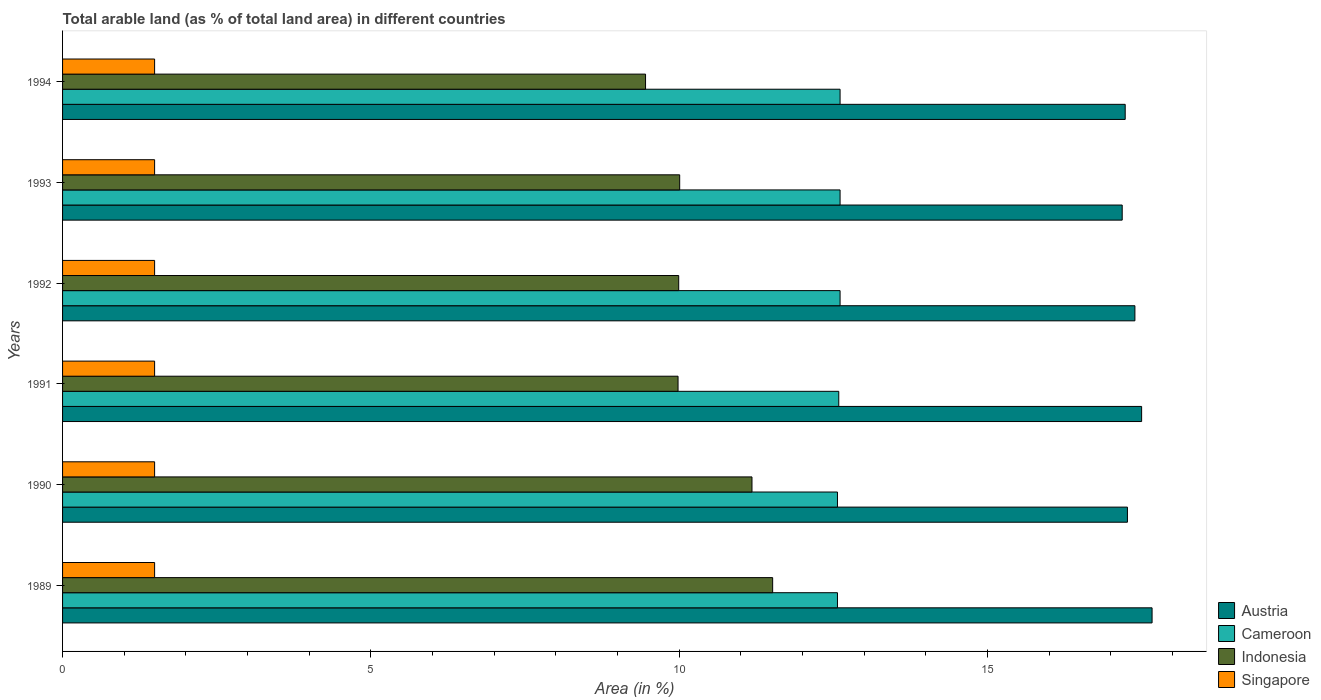How many groups of bars are there?
Provide a succinct answer. 6. Are the number of bars per tick equal to the number of legend labels?
Provide a succinct answer. Yes. Are the number of bars on each tick of the Y-axis equal?
Your answer should be very brief. Yes. How many bars are there on the 5th tick from the top?
Your answer should be compact. 4. How many bars are there on the 3rd tick from the bottom?
Provide a short and direct response. 4. What is the label of the 2nd group of bars from the top?
Give a very brief answer. 1993. What is the percentage of arable land in Austria in 1989?
Give a very brief answer. 17.67. Across all years, what is the maximum percentage of arable land in Singapore?
Offer a very short reply. 1.49. Across all years, what is the minimum percentage of arable land in Singapore?
Provide a short and direct response. 1.49. What is the total percentage of arable land in Austria in the graph?
Your response must be concise. 104.24. What is the difference between the percentage of arable land in Austria in 1992 and that in 1994?
Your response must be concise. 0.16. What is the difference between the percentage of arable land in Austria in 1992 and the percentage of arable land in Indonesia in 1991?
Ensure brevity in your answer.  7.41. What is the average percentage of arable land in Singapore per year?
Provide a short and direct response. 1.49. In the year 1992, what is the difference between the percentage of arable land in Indonesia and percentage of arable land in Cameroon?
Give a very brief answer. -2.62. What is the ratio of the percentage of arable land in Indonesia in 1990 to that in 1992?
Provide a succinct answer. 1.12. Is the difference between the percentage of arable land in Indonesia in 1992 and 1993 greater than the difference between the percentage of arable land in Cameroon in 1992 and 1993?
Provide a succinct answer. No. What is the difference between the highest and the lowest percentage of arable land in Austria?
Provide a succinct answer. 0.48. Is it the case that in every year, the sum of the percentage of arable land in Indonesia and percentage of arable land in Austria is greater than the sum of percentage of arable land in Singapore and percentage of arable land in Cameroon?
Your answer should be very brief. Yes. What does the 1st bar from the top in 1989 represents?
Give a very brief answer. Singapore. What does the 1st bar from the bottom in 1989 represents?
Keep it short and to the point. Austria. Are all the bars in the graph horizontal?
Ensure brevity in your answer.  Yes. What is the difference between two consecutive major ticks on the X-axis?
Keep it short and to the point. 5. Does the graph contain grids?
Your answer should be very brief. No. Where does the legend appear in the graph?
Keep it short and to the point. Bottom right. How many legend labels are there?
Provide a succinct answer. 4. How are the legend labels stacked?
Offer a terse response. Vertical. What is the title of the graph?
Give a very brief answer. Total arable land (as % of total land area) in different countries. Does "Mali" appear as one of the legend labels in the graph?
Provide a short and direct response. No. What is the label or title of the X-axis?
Provide a short and direct response. Area (in %). What is the Area (in %) in Austria in 1989?
Offer a terse response. 17.67. What is the Area (in %) in Cameroon in 1989?
Your answer should be compact. 12.57. What is the Area (in %) in Indonesia in 1989?
Provide a succinct answer. 11.51. What is the Area (in %) in Singapore in 1989?
Offer a very short reply. 1.49. What is the Area (in %) in Austria in 1990?
Provide a short and direct response. 17.27. What is the Area (in %) of Cameroon in 1990?
Offer a terse response. 12.57. What is the Area (in %) of Indonesia in 1990?
Your response must be concise. 11.18. What is the Area (in %) in Singapore in 1990?
Offer a terse response. 1.49. What is the Area (in %) of Austria in 1991?
Offer a very short reply. 17.5. What is the Area (in %) of Cameroon in 1991?
Offer a terse response. 12.59. What is the Area (in %) in Indonesia in 1991?
Provide a succinct answer. 9.98. What is the Area (in %) in Singapore in 1991?
Offer a very short reply. 1.49. What is the Area (in %) of Austria in 1992?
Offer a terse response. 17.39. What is the Area (in %) in Cameroon in 1992?
Ensure brevity in your answer.  12.61. What is the Area (in %) in Indonesia in 1992?
Offer a very short reply. 9.99. What is the Area (in %) of Singapore in 1992?
Provide a succinct answer. 1.49. What is the Area (in %) of Austria in 1993?
Offer a very short reply. 17.18. What is the Area (in %) of Cameroon in 1993?
Provide a succinct answer. 12.61. What is the Area (in %) of Indonesia in 1993?
Your response must be concise. 10.01. What is the Area (in %) in Singapore in 1993?
Give a very brief answer. 1.49. What is the Area (in %) of Austria in 1994?
Offer a very short reply. 17.23. What is the Area (in %) of Cameroon in 1994?
Provide a succinct answer. 12.61. What is the Area (in %) in Indonesia in 1994?
Provide a succinct answer. 9.45. What is the Area (in %) of Singapore in 1994?
Provide a succinct answer. 1.49. Across all years, what is the maximum Area (in %) in Austria?
Ensure brevity in your answer.  17.67. Across all years, what is the maximum Area (in %) in Cameroon?
Your answer should be very brief. 12.61. Across all years, what is the maximum Area (in %) of Indonesia?
Keep it short and to the point. 11.51. Across all years, what is the maximum Area (in %) of Singapore?
Ensure brevity in your answer.  1.49. Across all years, what is the minimum Area (in %) of Austria?
Provide a succinct answer. 17.18. Across all years, what is the minimum Area (in %) in Cameroon?
Offer a very short reply. 12.57. Across all years, what is the minimum Area (in %) in Indonesia?
Your answer should be compact. 9.45. Across all years, what is the minimum Area (in %) of Singapore?
Ensure brevity in your answer.  1.49. What is the total Area (in %) in Austria in the graph?
Your response must be concise. 104.24. What is the total Area (in %) of Cameroon in the graph?
Offer a terse response. 75.54. What is the total Area (in %) of Indonesia in the graph?
Offer a very short reply. 62.13. What is the total Area (in %) in Singapore in the graph?
Keep it short and to the point. 8.96. What is the difference between the Area (in %) in Austria in 1989 and that in 1990?
Provide a short and direct response. 0.4. What is the difference between the Area (in %) of Indonesia in 1989 and that in 1990?
Offer a terse response. 0.34. What is the difference between the Area (in %) of Singapore in 1989 and that in 1990?
Ensure brevity in your answer.  0. What is the difference between the Area (in %) of Austria in 1989 and that in 1991?
Keep it short and to the point. 0.17. What is the difference between the Area (in %) of Cameroon in 1989 and that in 1991?
Your response must be concise. -0.02. What is the difference between the Area (in %) in Indonesia in 1989 and that in 1991?
Your response must be concise. 1.53. What is the difference between the Area (in %) of Singapore in 1989 and that in 1991?
Provide a succinct answer. 0. What is the difference between the Area (in %) of Austria in 1989 and that in 1992?
Your answer should be very brief. 0.28. What is the difference between the Area (in %) in Cameroon in 1989 and that in 1992?
Offer a very short reply. -0.04. What is the difference between the Area (in %) in Indonesia in 1989 and that in 1992?
Provide a short and direct response. 1.52. What is the difference between the Area (in %) of Austria in 1989 and that in 1993?
Provide a succinct answer. 0.48. What is the difference between the Area (in %) in Cameroon in 1989 and that in 1993?
Provide a succinct answer. -0.04. What is the difference between the Area (in %) of Indonesia in 1989 and that in 1993?
Offer a terse response. 1.51. What is the difference between the Area (in %) in Austria in 1989 and that in 1994?
Offer a very short reply. 0.44. What is the difference between the Area (in %) of Cameroon in 1989 and that in 1994?
Your response must be concise. -0.04. What is the difference between the Area (in %) in Indonesia in 1989 and that in 1994?
Ensure brevity in your answer.  2.06. What is the difference between the Area (in %) in Austria in 1990 and that in 1991?
Your answer should be compact. -0.23. What is the difference between the Area (in %) of Cameroon in 1990 and that in 1991?
Offer a terse response. -0.02. What is the difference between the Area (in %) in Indonesia in 1990 and that in 1991?
Your answer should be very brief. 1.2. What is the difference between the Area (in %) of Austria in 1990 and that in 1992?
Make the answer very short. -0.12. What is the difference between the Area (in %) in Cameroon in 1990 and that in 1992?
Make the answer very short. -0.04. What is the difference between the Area (in %) of Indonesia in 1990 and that in 1992?
Your answer should be compact. 1.19. What is the difference between the Area (in %) in Austria in 1990 and that in 1993?
Your response must be concise. 0.08. What is the difference between the Area (in %) of Cameroon in 1990 and that in 1993?
Provide a succinct answer. -0.04. What is the difference between the Area (in %) of Indonesia in 1990 and that in 1993?
Your answer should be compact. 1.17. What is the difference between the Area (in %) in Singapore in 1990 and that in 1993?
Your answer should be compact. 0. What is the difference between the Area (in %) in Austria in 1990 and that in 1994?
Your answer should be compact. 0.04. What is the difference between the Area (in %) of Cameroon in 1990 and that in 1994?
Offer a very short reply. -0.04. What is the difference between the Area (in %) of Indonesia in 1990 and that in 1994?
Your response must be concise. 1.73. What is the difference between the Area (in %) of Austria in 1991 and that in 1992?
Ensure brevity in your answer.  0.11. What is the difference between the Area (in %) of Cameroon in 1991 and that in 1992?
Offer a very short reply. -0.02. What is the difference between the Area (in %) of Indonesia in 1991 and that in 1992?
Give a very brief answer. -0.01. What is the difference between the Area (in %) of Austria in 1991 and that in 1993?
Keep it short and to the point. 0.31. What is the difference between the Area (in %) of Cameroon in 1991 and that in 1993?
Provide a succinct answer. -0.02. What is the difference between the Area (in %) of Indonesia in 1991 and that in 1993?
Offer a very short reply. -0.03. What is the difference between the Area (in %) of Austria in 1991 and that in 1994?
Ensure brevity in your answer.  0.27. What is the difference between the Area (in %) of Cameroon in 1991 and that in 1994?
Your response must be concise. -0.02. What is the difference between the Area (in %) of Indonesia in 1991 and that in 1994?
Make the answer very short. 0.53. What is the difference between the Area (in %) in Austria in 1992 and that in 1993?
Ensure brevity in your answer.  0.21. What is the difference between the Area (in %) of Cameroon in 1992 and that in 1993?
Give a very brief answer. 0. What is the difference between the Area (in %) of Indonesia in 1992 and that in 1993?
Provide a short and direct response. -0.02. What is the difference between the Area (in %) of Austria in 1992 and that in 1994?
Provide a succinct answer. 0.16. What is the difference between the Area (in %) in Indonesia in 1992 and that in 1994?
Give a very brief answer. 0.54. What is the difference between the Area (in %) of Austria in 1993 and that in 1994?
Your response must be concise. -0.05. What is the difference between the Area (in %) in Cameroon in 1993 and that in 1994?
Offer a terse response. 0. What is the difference between the Area (in %) in Indonesia in 1993 and that in 1994?
Give a very brief answer. 0.55. What is the difference between the Area (in %) of Austria in 1989 and the Area (in %) of Cameroon in 1990?
Offer a very short reply. 5.1. What is the difference between the Area (in %) in Austria in 1989 and the Area (in %) in Indonesia in 1990?
Ensure brevity in your answer.  6.49. What is the difference between the Area (in %) of Austria in 1989 and the Area (in %) of Singapore in 1990?
Your answer should be compact. 16.18. What is the difference between the Area (in %) of Cameroon in 1989 and the Area (in %) of Indonesia in 1990?
Make the answer very short. 1.39. What is the difference between the Area (in %) in Cameroon in 1989 and the Area (in %) in Singapore in 1990?
Your response must be concise. 11.07. What is the difference between the Area (in %) of Indonesia in 1989 and the Area (in %) of Singapore in 1990?
Offer a very short reply. 10.02. What is the difference between the Area (in %) in Austria in 1989 and the Area (in %) in Cameroon in 1991?
Offer a terse response. 5.08. What is the difference between the Area (in %) in Austria in 1989 and the Area (in %) in Indonesia in 1991?
Your response must be concise. 7.69. What is the difference between the Area (in %) in Austria in 1989 and the Area (in %) in Singapore in 1991?
Provide a succinct answer. 16.18. What is the difference between the Area (in %) of Cameroon in 1989 and the Area (in %) of Indonesia in 1991?
Give a very brief answer. 2.58. What is the difference between the Area (in %) in Cameroon in 1989 and the Area (in %) in Singapore in 1991?
Provide a short and direct response. 11.07. What is the difference between the Area (in %) in Indonesia in 1989 and the Area (in %) in Singapore in 1991?
Offer a very short reply. 10.02. What is the difference between the Area (in %) in Austria in 1989 and the Area (in %) in Cameroon in 1992?
Ensure brevity in your answer.  5.06. What is the difference between the Area (in %) in Austria in 1989 and the Area (in %) in Indonesia in 1992?
Your answer should be very brief. 7.68. What is the difference between the Area (in %) of Austria in 1989 and the Area (in %) of Singapore in 1992?
Give a very brief answer. 16.18. What is the difference between the Area (in %) in Cameroon in 1989 and the Area (in %) in Indonesia in 1992?
Provide a succinct answer. 2.57. What is the difference between the Area (in %) in Cameroon in 1989 and the Area (in %) in Singapore in 1992?
Your answer should be compact. 11.07. What is the difference between the Area (in %) in Indonesia in 1989 and the Area (in %) in Singapore in 1992?
Give a very brief answer. 10.02. What is the difference between the Area (in %) in Austria in 1989 and the Area (in %) in Cameroon in 1993?
Offer a very short reply. 5.06. What is the difference between the Area (in %) of Austria in 1989 and the Area (in %) of Indonesia in 1993?
Offer a terse response. 7.66. What is the difference between the Area (in %) in Austria in 1989 and the Area (in %) in Singapore in 1993?
Offer a very short reply. 16.18. What is the difference between the Area (in %) in Cameroon in 1989 and the Area (in %) in Indonesia in 1993?
Give a very brief answer. 2.56. What is the difference between the Area (in %) of Cameroon in 1989 and the Area (in %) of Singapore in 1993?
Offer a terse response. 11.07. What is the difference between the Area (in %) of Indonesia in 1989 and the Area (in %) of Singapore in 1993?
Ensure brevity in your answer.  10.02. What is the difference between the Area (in %) of Austria in 1989 and the Area (in %) of Cameroon in 1994?
Your answer should be compact. 5.06. What is the difference between the Area (in %) of Austria in 1989 and the Area (in %) of Indonesia in 1994?
Your answer should be compact. 8.21. What is the difference between the Area (in %) of Austria in 1989 and the Area (in %) of Singapore in 1994?
Offer a terse response. 16.18. What is the difference between the Area (in %) of Cameroon in 1989 and the Area (in %) of Indonesia in 1994?
Offer a terse response. 3.11. What is the difference between the Area (in %) of Cameroon in 1989 and the Area (in %) of Singapore in 1994?
Offer a very short reply. 11.07. What is the difference between the Area (in %) of Indonesia in 1989 and the Area (in %) of Singapore in 1994?
Your answer should be very brief. 10.02. What is the difference between the Area (in %) of Austria in 1990 and the Area (in %) of Cameroon in 1991?
Give a very brief answer. 4.68. What is the difference between the Area (in %) in Austria in 1990 and the Area (in %) in Indonesia in 1991?
Make the answer very short. 7.29. What is the difference between the Area (in %) in Austria in 1990 and the Area (in %) in Singapore in 1991?
Give a very brief answer. 15.78. What is the difference between the Area (in %) of Cameroon in 1990 and the Area (in %) of Indonesia in 1991?
Your answer should be compact. 2.58. What is the difference between the Area (in %) of Cameroon in 1990 and the Area (in %) of Singapore in 1991?
Offer a terse response. 11.07. What is the difference between the Area (in %) in Indonesia in 1990 and the Area (in %) in Singapore in 1991?
Make the answer very short. 9.69. What is the difference between the Area (in %) in Austria in 1990 and the Area (in %) in Cameroon in 1992?
Your response must be concise. 4.66. What is the difference between the Area (in %) of Austria in 1990 and the Area (in %) of Indonesia in 1992?
Your answer should be compact. 7.28. What is the difference between the Area (in %) in Austria in 1990 and the Area (in %) in Singapore in 1992?
Offer a terse response. 15.78. What is the difference between the Area (in %) of Cameroon in 1990 and the Area (in %) of Indonesia in 1992?
Your answer should be compact. 2.57. What is the difference between the Area (in %) in Cameroon in 1990 and the Area (in %) in Singapore in 1992?
Offer a very short reply. 11.07. What is the difference between the Area (in %) of Indonesia in 1990 and the Area (in %) of Singapore in 1992?
Your answer should be compact. 9.69. What is the difference between the Area (in %) of Austria in 1990 and the Area (in %) of Cameroon in 1993?
Keep it short and to the point. 4.66. What is the difference between the Area (in %) in Austria in 1990 and the Area (in %) in Indonesia in 1993?
Ensure brevity in your answer.  7.26. What is the difference between the Area (in %) in Austria in 1990 and the Area (in %) in Singapore in 1993?
Offer a very short reply. 15.78. What is the difference between the Area (in %) in Cameroon in 1990 and the Area (in %) in Indonesia in 1993?
Your response must be concise. 2.56. What is the difference between the Area (in %) in Cameroon in 1990 and the Area (in %) in Singapore in 1993?
Offer a terse response. 11.07. What is the difference between the Area (in %) in Indonesia in 1990 and the Area (in %) in Singapore in 1993?
Ensure brevity in your answer.  9.69. What is the difference between the Area (in %) of Austria in 1990 and the Area (in %) of Cameroon in 1994?
Keep it short and to the point. 4.66. What is the difference between the Area (in %) of Austria in 1990 and the Area (in %) of Indonesia in 1994?
Keep it short and to the point. 7.81. What is the difference between the Area (in %) in Austria in 1990 and the Area (in %) in Singapore in 1994?
Your response must be concise. 15.78. What is the difference between the Area (in %) of Cameroon in 1990 and the Area (in %) of Indonesia in 1994?
Make the answer very short. 3.11. What is the difference between the Area (in %) of Cameroon in 1990 and the Area (in %) of Singapore in 1994?
Your response must be concise. 11.07. What is the difference between the Area (in %) in Indonesia in 1990 and the Area (in %) in Singapore in 1994?
Your answer should be very brief. 9.69. What is the difference between the Area (in %) in Austria in 1991 and the Area (in %) in Cameroon in 1992?
Provide a succinct answer. 4.89. What is the difference between the Area (in %) in Austria in 1991 and the Area (in %) in Indonesia in 1992?
Provide a short and direct response. 7.51. What is the difference between the Area (in %) of Austria in 1991 and the Area (in %) of Singapore in 1992?
Provide a succinct answer. 16.01. What is the difference between the Area (in %) of Cameroon in 1991 and the Area (in %) of Indonesia in 1992?
Your answer should be compact. 2.6. What is the difference between the Area (in %) in Cameroon in 1991 and the Area (in %) in Singapore in 1992?
Offer a terse response. 11.09. What is the difference between the Area (in %) in Indonesia in 1991 and the Area (in %) in Singapore in 1992?
Offer a very short reply. 8.49. What is the difference between the Area (in %) in Austria in 1991 and the Area (in %) in Cameroon in 1993?
Offer a very short reply. 4.89. What is the difference between the Area (in %) of Austria in 1991 and the Area (in %) of Indonesia in 1993?
Give a very brief answer. 7.49. What is the difference between the Area (in %) in Austria in 1991 and the Area (in %) in Singapore in 1993?
Your response must be concise. 16.01. What is the difference between the Area (in %) of Cameroon in 1991 and the Area (in %) of Indonesia in 1993?
Your response must be concise. 2.58. What is the difference between the Area (in %) in Cameroon in 1991 and the Area (in %) in Singapore in 1993?
Your answer should be very brief. 11.09. What is the difference between the Area (in %) in Indonesia in 1991 and the Area (in %) in Singapore in 1993?
Keep it short and to the point. 8.49. What is the difference between the Area (in %) of Austria in 1991 and the Area (in %) of Cameroon in 1994?
Provide a succinct answer. 4.89. What is the difference between the Area (in %) in Austria in 1991 and the Area (in %) in Indonesia in 1994?
Keep it short and to the point. 8.04. What is the difference between the Area (in %) in Austria in 1991 and the Area (in %) in Singapore in 1994?
Offer a very short reply. 16.01. What is the difference between the Area (in %) in Cameroon in 1991 and the Area (in %) in Indonesia in 1994?
Keep it short and to the point. 3.13. What is the difference between the Area (in %) of Cameroon in 1991 and the Area (in %) of Singapore in 1994?
Ensure brevity in your answer.  11.09. What is the difference between the Area (in %) in Indonesia in 1991 and the Area (in %) in Singapore in 1994?
Ensure brevity in your answer.  8.49. What is the difference between the Area (in %) of Austria in 1992 and the Area (in %) of Cameroon in 1993?
Ensure brevity in your answer.  4.78. What is the difference between the Area (in %) in Austria in 1992 and the Area (in %) in Indonesia in 1993?
Make the answer very short. 7.38. What is the difference between the Area (in %) of Austria in 1992 and the Area (in %) of Singapore in 1993?
Offer a very short reply. 15.9. What is the difference between the Area (in %) of Cameroon in 1992 and the Area (in %) of Indonesia in 1993?
Your response must be concise. 2.6. What is the difference between the Area (in %) in Cameroon in 1992 and the Area (in %) in Singapore in 1993?
Offer a very short reply. 11.12. What is the difference between the Area (in %) of Indonesia in 1992 and the Area (in %) of Singapore in 1993?
Your answer should be compact. 8.5. What is the difference between the Area (in %) in Austria in 1992 and the Area (in %) in Cameroon in 1994?
Your response must be concise. 4.78. What is the difference between the Area (in %) of Austria in 1992 and the Area (in %) of Indonesia in 1994?
Ensure brevity in your answer.  7.94. What is the difference between the Area (in %) of Austria in 1992 and the Area (in %) of Singapore in 1994?
Provide a short and direct response. 15.9. What is the difference between the Area (in %) in Cameroon in 1992 and the Area (in %) in Indonesia in 1994?
Ensure brevity in your answer.  3.15. What is the difference between the Area (in %) of Cameroon in 1992 and the Area (in %) of Singapore in 1994?
Provide a succinct answer. 11.12. What is the difference between the Area (in %) of Indonesia in 1992 and the Area (in %) of Singapore in 1994?
Provide a short and direct response. 8.5. What is the difference between the Area (in %) of Austria in 1993 and the Area (in %) of Cameroon in 1994?
Your response must be concise. 4.58. What is the difference between the Area (in %) in Austria in 1993 and the Area (in %) in Indonesia in 1994?
Provide a short and direct response. 7.73. What is the difference between the Area (in %) of Austria in 1993 and the Area (in %) of Singapore in 1994?
Offer a very short reply. 15.69. What is the difference between the Area (in %) in Cameroon in 1993 and the Area (in %) in Indonesia in 1994?
Your answer should be very brief. 3.15. What is the difference between the Area (in %) of Cameroon in 1993 and the Area (in %) of Singapore in 1994?
Provide a short and direct response. 11.12. What is the difference between the Area (in %) of Indonesia in 1993 and the Area (in %) of Singapore in 1994?
Your answer should be very brief. 8.51. What is the average Area (in %) of Austria per year?
Make the answer very short. 17.37. What is the average Area (in %) in Cameroon per year?
Provide a succinct answer. 12.59. What is the average Area (in %) in Indonesia per year?
Provide a succinct answer. 10.35. What is the average Area (in %) of Singapore per year?
Provide a succinct answer. 1.49. In the year 1989, what is the difference between the Area (in %) of Austria and Area (in %) of Cameroon?
Your response must be concise. 5.1. In the year 1989, what is the difference between the Area (in %) in Austria and Area (in %) in Indonesia?
Give a very brief answer. 6.15. In the year 1989, what is the difference between the Area (in %) in Austria and Area (in %) in Singapore?
Your answer should be compact. 16.18. In the year 1989, what is the difference between the Area (in %) in Cameroon and Area (in %) in Indonesia?
Give a very brief answer. 1.05. In the year 1989, what is the difference between the Area (in %) of Cameroon and Area (in %) of Singapore?
Provide a short and direct response. 11.07. In the year 1989, what is the difference between the Area (in %) in Indonesia and Area (in %) in Singapore?
Offer a terse response. 10.02. In the year 1990, what is the difference between the Area (in %) in Austria and Area (in %) in Cameroon?
Keep it short and to the point. 4.7. In the year 1990, what is the difference between the Area (in %) of Austria and Area (in %) of Indonesia?
Provide a succinct answer. 6.09. In the year 1990, what is the difference between the Area (in %) in Austria and Area (in %) in Singapore?
Your answer should be very brief. 15.78. In the year 1990, what is the difference between the Area (in %) in Cameroon and Area (in %) in Indonesia?
Ensure brevity in your answer.  1.39. In the year 1990, what is the difference between the Area (in %) in Cameroon and Area (in %) in Singapore?
Give a very brief answer. 11.07. In the year 1990, what is the difference between the Area (in %) of Indonesia and Area (in %) of Singapore?
Provide a short and direct response. 9.69. In the year 1991, what is the difference between the Area (in %) of Austria and Area (in %) of Cameroon?
Offer a very short reply. 4.91. In the year 1991, what is the difference between the Area (in %) in Austria and Area (in %) in Indonesia?
Your answer should be compact. 7.52. In the year 1991, what is the difference between the Area (in %) in Austria and Area (in %) in Singapore?
Offer a very short reply. 16.01. In the year 1991, what is the difference between the Area (in %) of Cameroon and Area (in %) of Indonesia?
Offer a very short reply. 2.61. In the year 1991, what is the difference between the Area (in %) in Cameroon and Area (in %) in Singapore?
Ensure brevity in your answer.  11.09. In the year 1991, what is the difference between the Area (in %) of Indonesia and Area (in %) of Singapore?
Provide a succinct answer. 8.49. In the year 1992, what is the difference between the Area (in %) of Austria and Area (in %) of Cameroon?
Keep it short and to the point. 4.78. In the year 1992, what is the difference between the Area (in %) in Austria and Area (in %) in Indonesia?
Ensure brevity in your answer.  7.4. In the year 1992, what is the difference between the Area (in %) of Austria and Area (in %) of Singapore?
Make the answer very short. 15.9. In the year 1992, what is the difference between the Area (in %) of Cameroon and Area (in %) of Indonesia?
Your answer should be very brief. 2.62. In the year 1992, what is the difference between the Area (in %) in Cameroon and Area (in %) in Singapore?
Provide a succinct answer. 11.12. In the year 1992, what is the difference between the Area (in %) in Indonesia and Area (in %) in Singapore?
Ensure brevity in your answer.  8.5. In the year 1993, what is the difference between the Area (in %) in Austria and Area (in %) in Cameroon?
Offer a very short reply. 4.58. In the year 1993, what is the difference between the Area (in %) of Austria and Area (in %) of Indonesia?
Your response must be concise. 7.18. In the year 1993, what is the difference between the Area (in %) of Austria and Area (in %) of Singapore?
Give a very brief answer. 15.69. In the year 1993, what is the difference between the Area (in %) in Cameroon and Area (in %) in Indonesia?
Your answer should be compact. 2.6. In the year 1993, what is the difference between the Area (in %) of Cameroon and Area (in %) of Singapore?
Give a very brief answer. 11.12. In the year 1993, what is the difference between the Area (in %) of Indonesia and Area (in %) of Singapore?
Your response must be concise. 8.51. In the year 1994, what is the difference between the Area (in %) in Austria and Area (in %) in Cameroon?
Give a very brief answer. 4.62. In the year 1994, what is the difference between the Area (in %) in Austria and Area (in %) in Indonesia?
Your answer should be compact. 7.78. In the year 1994, what is the difference between the Area (in %) in Austria and Area (in %) in Singapore?
Your answer should be compact. 15.74. In the year 1994, what is the difference between the Area (in %) in Cameroon and Area (in %) in Indonesia?
Offer a very short reply. 3.15. In the year 1994, what is the difference between the Area (in %) in Cameroon and Area (in %) in Singapore?
Your answer should be very brief. 11.12. In the year 1994, what is the difference between the Area (in %) of Indonesia and Area (in %) of Singapore?
Provide a succinct answer. 7.96. What is the ratio of the Area (in %) of Austria in 1989 to that in 1990?
Keep it short and to the point. 1.02. What is the ratio of the Area (in %) of Indonesia in 1989 to that in 1990?
Offer a very short reply. 1.03. What is the ratio of the Area (in %) in Singapore in 1989 to that in 1990?
Provide a short and direct response. 1. What is the ratio of the Area (in %) in Austria in 1989 to that in 1991?
Offer a very short reply. 1.01. What is the ratio of the Area (in %) in Cameroon in 1989 to that in 1991?
Ensure brevity in your answer.  1. What is the ratio of the Area (in %) of Indonesia in 1989 to that in 1991?
Make the answer very short. 1.15. What is the ratio of the Area (in %) of Austria in 1989 to that in 1992?
Give a very brief answer. 1.02. What is the ratio of the Area (in %) in Indonesia in 1989 to that in 1992?
Offer a very short reply. 1.15. What is the ratio of the Area (in %) in Singapore in 1989 to that in 1992?
Offer a very short reply. 1. What is the ratio of the Area (in %) of Austria in 1989 to that in 1993?
Offer a terse response. 1.03. What is the ratio of the Area (in %) in Cameroon in 1989 to that in 1993?
Offer a terse response. 1. What is the ratio of the Area (in %) in Indonesia in 1989 to that in 1993?
Offer a terse response. 1.15. What is the ratio of the Area (in %) of Singapore in 1989 to that in 1993?
Give a very brief answer. 1. What is the ratio of the Area (in %) in Austria in 1989 to that in 1994?
Make the answer very short. 1.03. What is the ratio of the Area (in %) of Indonesia in 1989 to that in 1994?
Offer a terse response. 1.22. What is the ratio of the Area (in %) of Singapore in 1989 to that in 1994?
Keep it short and to the point. 1. What is the ratio of the Area (in %) of Austria in 1990 to that in 1991?
Provide a succinct answer. 0.99. What is the ratio of the Area (in %) in Cameroon in 1990 to that in 1991?
Offer a very short reply. 1. What is the ratio of the Area (in %) of Indonesia in 1990 to that in 1991?
Give a very brief answer. 1.12. What is the ratio of the Area (in %) of Singapore in 1990 to that in 1991?
Keep it short and to the point. 1. What is the ratio of the Area (in %) in Cameroon in 1990 to that in 1992?
Keep it short and to the point. 1. What is the ratio of the Area (in %) of Indonesia in 1990 to that in 1992?
Your response must be concise. 1.12. What is the ratio of the Area (in %) of Indonesia in 1990 to that in 1993?
Give a very brief answer. 1.12. What is the ratio of the Area (in %) in Singapore in 1990 to that in 1993?
Offer a very short reply. 1. What is the ratio of the Area (in %) in Cameroon in 1990 to that in 1994?
Ensure brevity in your answer.  1. What is the ratio of the Area (in %) of Indonesia in 1990 to that in 1994?
Provide a succinct answer. 1.18. What is the ratio of the Area (in %) in Singapore in 1991 to that in 1992?
Provide a succinct answer. 1. What is the ratio of the Area (in %) in Austria in 1991 to that in 1993?
Offer a terse response. 1.02. What is the ratio of the Area (in %) of Cameroon in 1991 to that in 1993?
Your answer should be very brief. 1. What is the ratio of the Area (in %) in Indonesia in 1991 to that in 1993?
Keep it short and to the point. 1. What is the ratio of the Area (in %) of Singapore in 1991 to that in 1993?
Make the answer very short. 1. What is the ratio of the Area (in %) in Austria in 1991 to that in 1994?
Provide a short and direct response. 1.02. What is the ratio of the Area (in %) of Indonesia in 1991 to that in 1994?
Give a very brief answer. 1.06. What is the ratio of the Area (in %) in Cameroon in 1992 to that in 1993?
Offer a terse response. 1. What is the ratio of the Area (in %) of Indonesia in 1992 to that in 1993?
Your answer should be very brief. 1. What is the ratio of the Area (in %) in Austria in 1992 to that in 1994?
Offer a very short reply. 1.01. What is the ratio of the Area (in %) of Cameroon in 1992 to that in 1994?
Make the answer very short. 1. What is the ratio of the Area (in %) of Indonesia in 1992 to that in 1994?
Keep it short and to the point. 1.06. What is the ratio of the Area (in %) in Austria in 1993 to that in 1994?
Make the answer very short. 1. What is the ratio of the Area (in %) of Indonesia in 1993 to that in 1994?
Offer a terse response. 1.06. What is the ratio of the Area (in %) in Singapore in 1993 to that in 1994?
Provide a succinct answer. 1. What is the difference between the highest and the second highest Area (in %) in Austria?
Ensure brevity in your answer.  0.17. What is the difference between the highest and the second highest Area (in %) of Cameroon?
Provide a short and direct response. 0. What is the difference between the highest and the second highest Area (in %) in Indonesia?
Offer a very short reply. 0.34. What is the difference between the highest and the lowest Area (in %) in Austria?
Your response must be concise. 0.48. What is the difference between the highest and the lowest Area (in %) of Cameroon?
Make the answer very short. 0.04. What is the difference between the highest and the lowest Area (in %) of Indonesia?
Keep it short and to the point. 2.06. What is the difference between the highest and the lowest Area (in %) in Singapore?
Offer a very short reply. 0. 